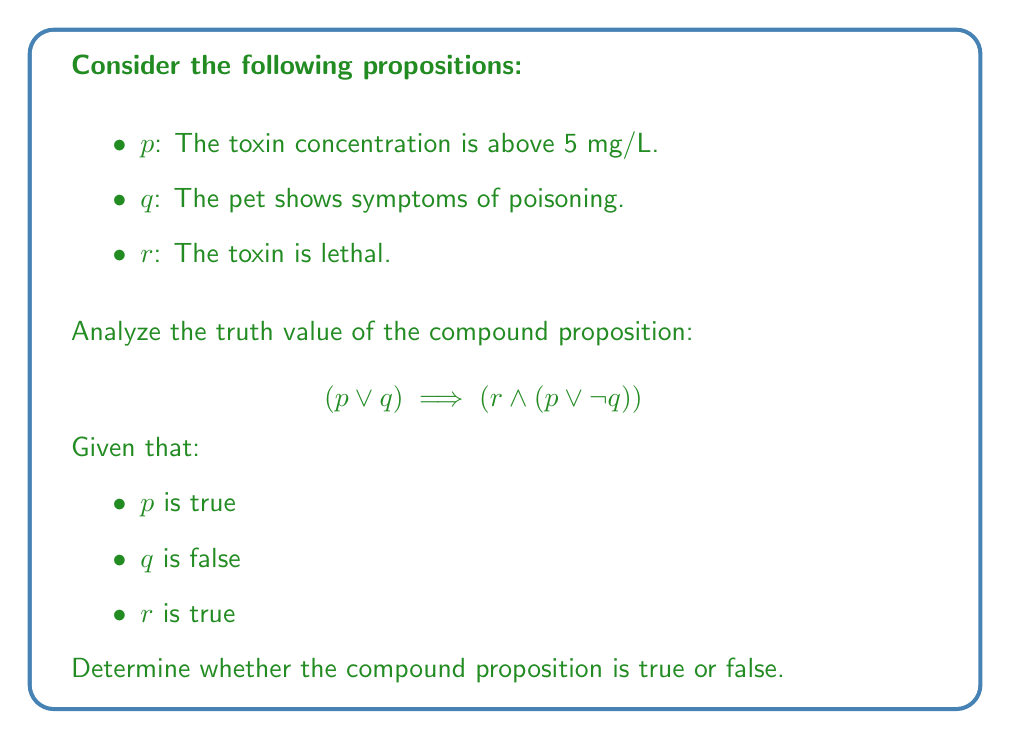Provide a solution to this math problem. Let's break this down step-by-step:

1) First, let's evaluate the truth values of the individual propositions:
   p: true
   q: false
   r: true

2) Now, let's evaluate the left side of the implication: $(p \lor q)$
   - $p$ is true, $q$ is false
   - true $\lor$ false = true

3) Next, let's evaluate the right side of the implication: $(r \land (p \lor \lnot q))$
   a) First, $(p \lor \lnot q)$:
      - $p$ is true, $\lnot q$ is true (since $q$ is false)
      - true $\lor$ true = true
   b) Now, $r \land$ (result from a):
      - $r$ is true, $(p \lor \lnot q)$ is true
      - true $\land$ true = true

4) Finally, we evaluate the implication:
   $(p \lor q) \implies (r \land (p \lor \lnot q))$
   - Left side is true, right side is true
   - true $\implies$ true = true

In propositional logic, when both the antecedent and consequent of an implication are true, the entire implication is true.
Answer: True 